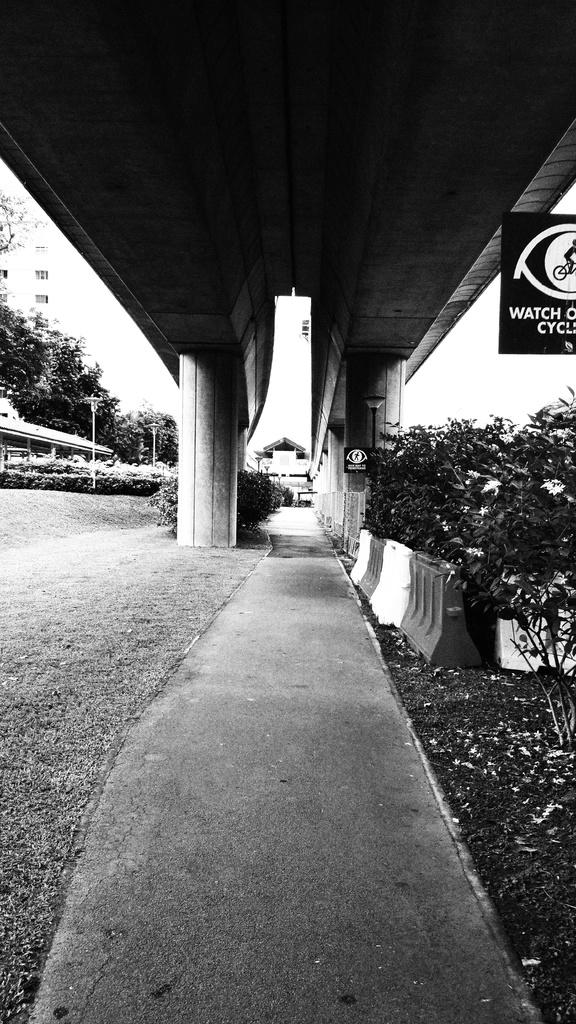What is the color scheme of the image? The image is black and white. What type of object can be seen in the image that is used for safety purposes? There is a road barrier in the image. What type of vegetation is present in the image? Grass, a plant, and trees are visible in the image. What type of structure can be seen in the image? There is a building in the image. What type of objects are present in the image that support or hold up other structures? Pillars and poles are present in the image. What type of object can be seen in the image that is used for displaying information or advertisements? There is a board in the image. What type of apparel is being worn by the rock in the image? There is no rock present in the image, and therefore no apparel can be associated with it. 